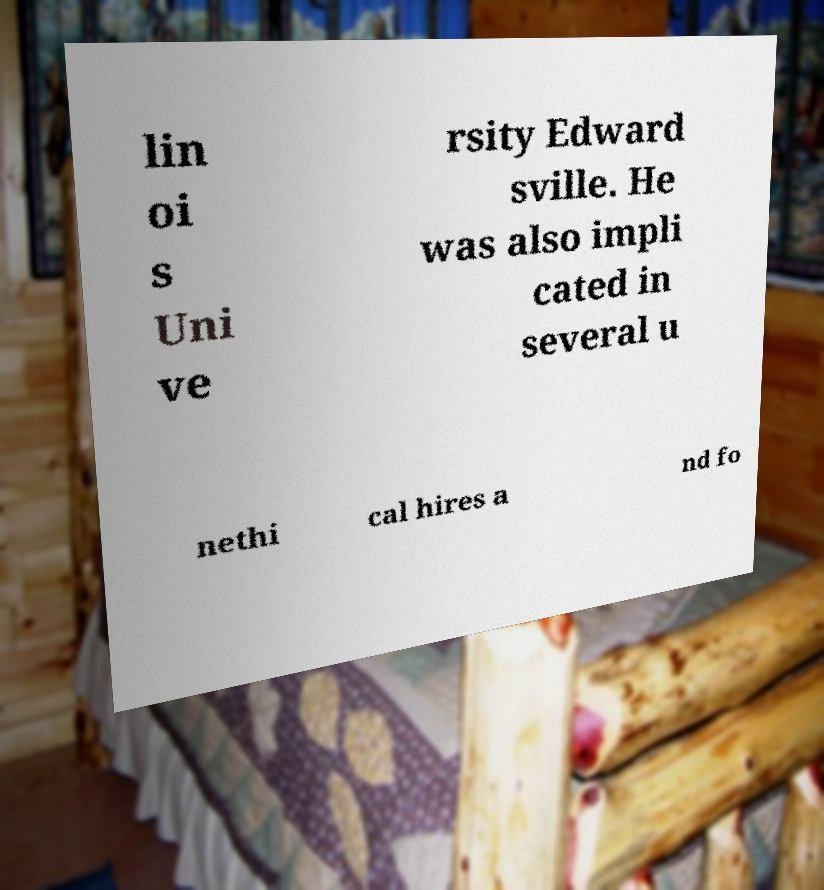Please read and relay the text visible in this image. What does it say? lin oi s Uni ve rsity Edward sville. He was also impli cated in several u nethi cal hires a nd fo 